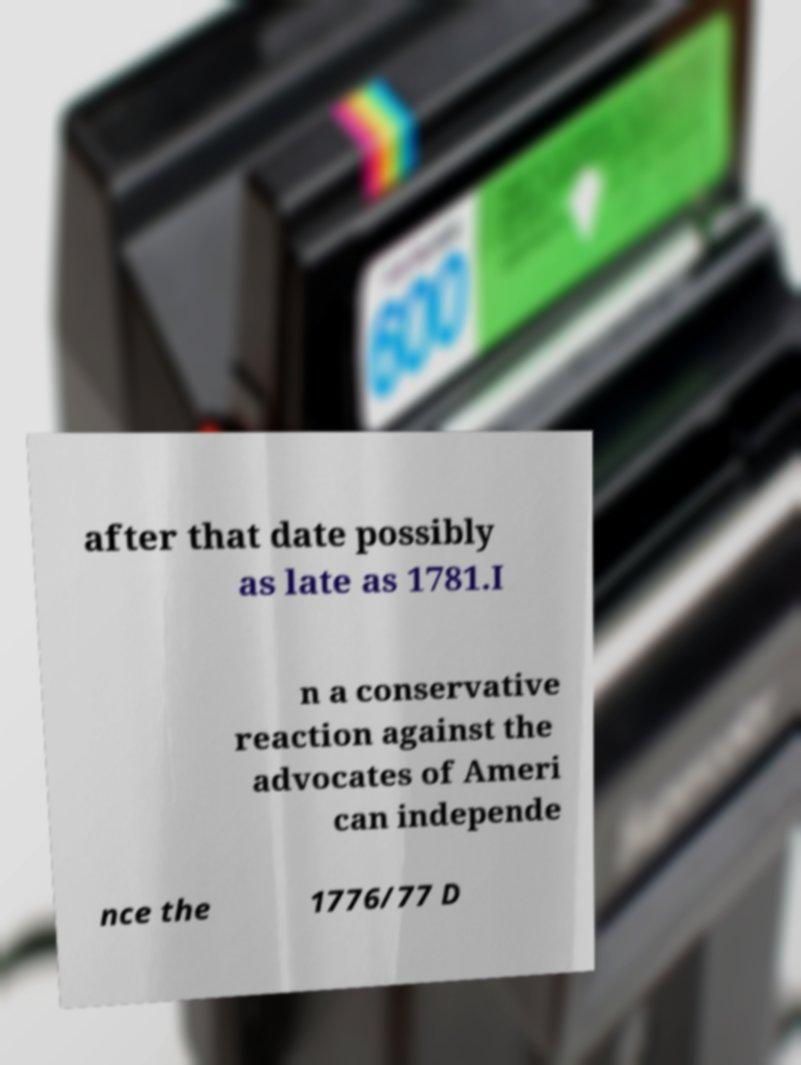Please identify and transcribe the text found in this image. after that date possibly as late as 1781.I n a conservative reaction against the advocates of Ameri can independe nce the 1776/77 D 